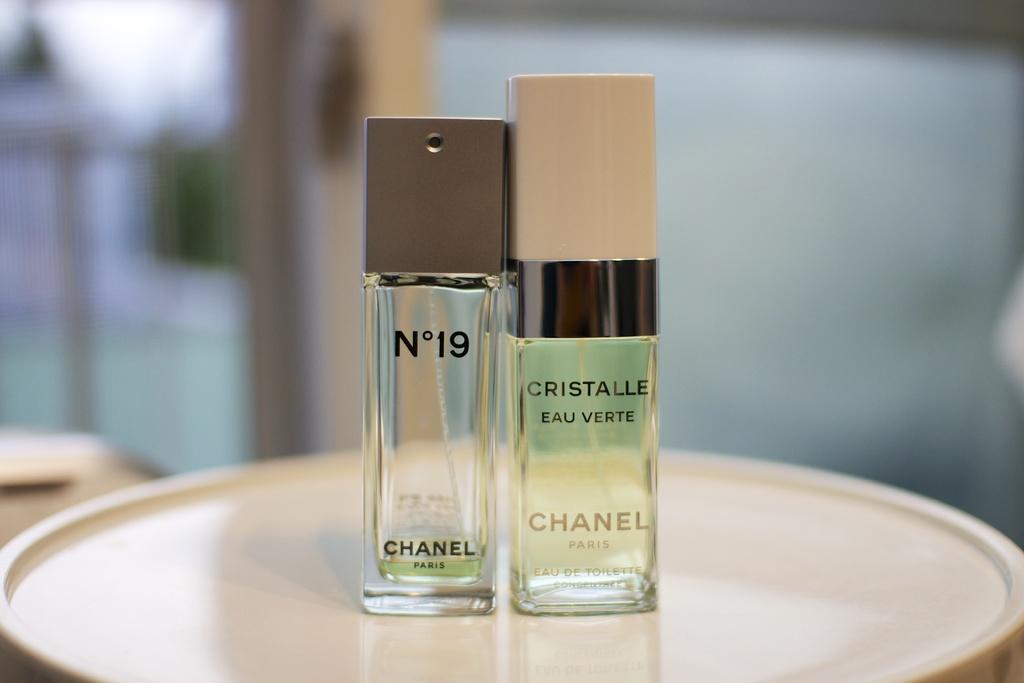What number perfume is this?
Keep it short and to the point. 19. 